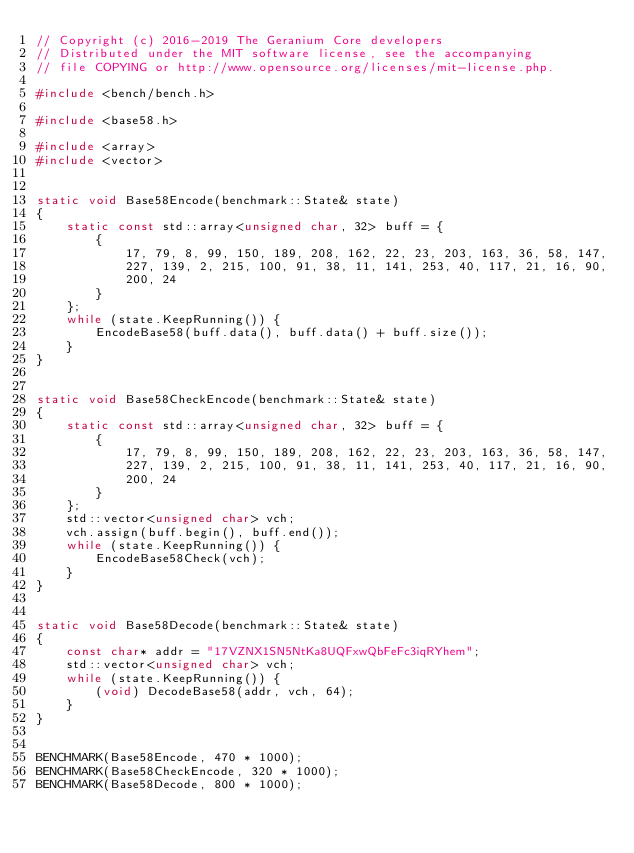Convert code to text. <code><loc_0><loc_0><loc_500><loc_500><_C++_>// Copyright (c) 2016-2019 The Geranium Core developers
// Distributed under the MIT software license, see the accompanying
// file COPYING or http://www.opensource.org/licenses/mit-license.php.

#include <bench/bench.h>

#include <base58.h>

#include <array>
#include <vector>


static void Base58Encode(benchmark::State& state)
{
    static const std::array<unsigned char, 32> buff = {
        {
            17, 79, 8, 99, 150, 189, 208, 162, 22, 23, 203, 163, 36, 58, 147,
            227, 139, 2, 215, 100, 91, 38, 11, 141, 253, 40, 117, 21, 16, 90,
            200, 24
        }
    };
    while (state.KeepRunning()) {
        EncodeBase58(buff.data(), buff.data() + buff.size());
    }
}


static void Base58CheckEncode(benchmark::State& state)
{
    static const std::array<unsigned char, 32> buff = {
        {
            17, 79, 8, 99, 150, 189, 208, 162, 22, 23, 203, 163, 36, 58, 147,
            227, 139, 2, 215, 100, 91, 38, 11, 141, 253, 40, 117, 21, 16, 90,
            200, 24
        }
    };
    std::vector<unsigned char> vch;
    vch.assign(buff.begin(), buff.end());
    while (state.KeepRunning()) {
        EncodeBase58Check(vch);
    }
}


static void Base58Decode(benchmark::State& state)
{
    const char* addr = "17VZNX1SN5NtKa8UQFxwQbFeFc3iqRYhem";
    std::vector<unsigned char> vch;
    while (state.KeepRunning()) {
        (void) DecodeBase58(addr, vch, 64);
    }
}


BENCHMARK(Base58Encode, 470 * 1000);
BENCHMARK(Base58CheckEncode, 320 * 1000);
BENCHMARK(Base58Decode, 800 * 1000);
</code> 